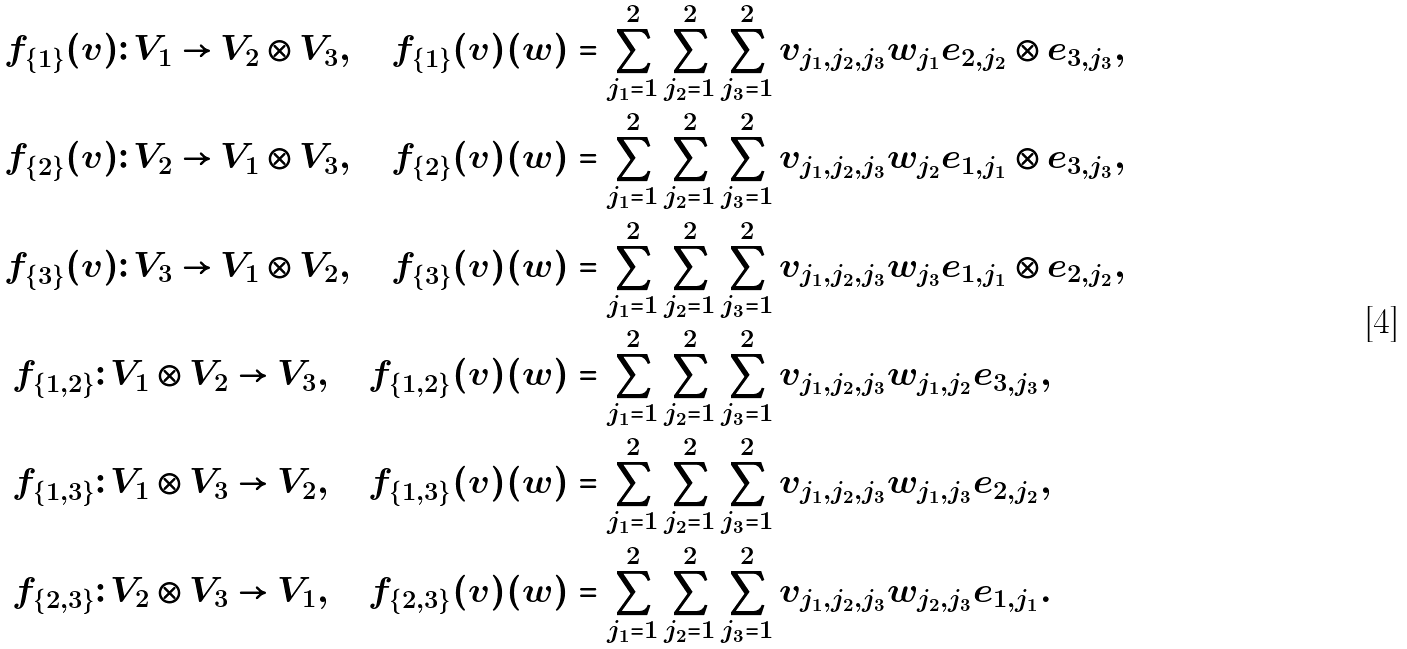<formula> <loc_0><loc_0><loc_500><loc_500>f _ { \{ 1 \} } ( v ) \colon V _ { 1 } \to V _ { 2 } \otimes V _ { 3 } , \quad f _ { \{ 1 \} } ( v ) ( w ) & = \sum _ { j _ { 1 } = 1 } ^ { 2 } \sum _ { j _ { 2 } = 1 } ^ { 2 } \sum _ { j _ { 3 } = 1 } ^ { 2 } v _ { j _ { 1 } , j _ { 2 } , j _ { 3 } } w _ { j _ { 1 } } e _ { 2 , j _ { 2 } } \otimes e _ { 3 , j _ { 3 } } , \\ f _ { \{ 2 \} } ( v ) \colon V _ { 2 } \to V _ { 1 } \otimes V _ { 3 } , \quad f _ { \{ 2 \} } ( v ) ( w ) & = \sum _ { j _ { 1 } = 1 } ^ { 2 } \sum _ { j _ { 2 } = 1 } ^ { 2 } \sum _ { j _ { 3 } = 1 } ^ { 2 } v _ { j _ { 1 } , j _ { 2 } , j _ { 3 } } w _ { j _ { 2 } } e _ { 1 , j _ { 1 } } \otimes e _ { 3 , j _ { 3 } } , \\ f _ { \{ 3 \} } ( v ) \colon V _ { 3 } \to V _ { 1 } \otimes V _ { 2 } , \quad f _ { \{ 3 \} } ( v ) ( w ) & = \sum _ { j _ { 1 } = 1 } ^ { 2 } \sum _ { j _ { 2 } = 1 } ^ { 2 } \sum _ { j _ { 3 } = 1 } ^ { 2 } v _ { j _ { 1 } , j _ { 2 } , j _ { 3 } } w _ { j _ { 3 } } e _ { 1 , j _ { 1 } } \otimes e _ { 2 , j _ { 2 } } , \\ f _ { \{ 1 , 2 \} } \colon V _ { 1 } \otimes V _ { 2 } \to V _ { 3 } , \quad f _ { \{ 1 , 2 \} } ( v ) ( w ) & = \sum _ { j _ { 1 } = 1 } ^ { 2 } \sum _ { j _ { 2 } = 1 } ^ { 2 } \sum _ { j _ { 3 } = 1 } ^ { 2 } v _ { j _ { 1 } , j _ { 2 } , j _ { 3 } } w _ { j _ { 1 } , j _ { 2 } } e _ { 3 , j _ { 3 } } , \\ f _ { \{ 1 , 3 \} } \colon V _ { 1 } \otimes V _ { 3 } \to V _ { 2 } , \quad f _ { \{ 1 , 3 \} } ( v ) ( w ) & = \sum _ { j _ { 1 } = 1 } ^ { 2 } \sum _ { j _ { 2 } = 1 } ^ { 2 } \sum _ { j _ { 3 } = 1 } ^ { 2 } v _ { j _ { 1 } , j _ { 2 } , j _ { 3 } } w _ { j _ { 1 } , j _ { 3 } } e _ { 2 , j _ { 2 } } , \\ f _ { \{ 2 , 3 \} } \colon V _ { 2 } \otimes V _ { 3 } \to V _ { 1 } , \quad f _ { \{ 2 , 3 \} } ( v ) ( w ) & = \sum _ { j _ { 1 } = 1 } ^ { 2 } \sum _ { j _ { 2 } = 1 } ^ { 2 } \sum _ { j _ { 3 } = 1 } ^ { 2 } v _ { j _ { 1 } , j _ { 2 } , j _ { 3 } } w _ { j _ { 2 } , j _ { 3 } } e _ { 1 , j _ { 1 } } .</formula> 